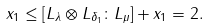<formula> <loc_0><loc_0><loc_500><loc_500>x _ { 1 } \leq [ L _ { \lambda } \otimes L _ { \delta _ { 1 } } \colon L _ { \mu } ] + x _ { 1 } = 2 .</formula> 